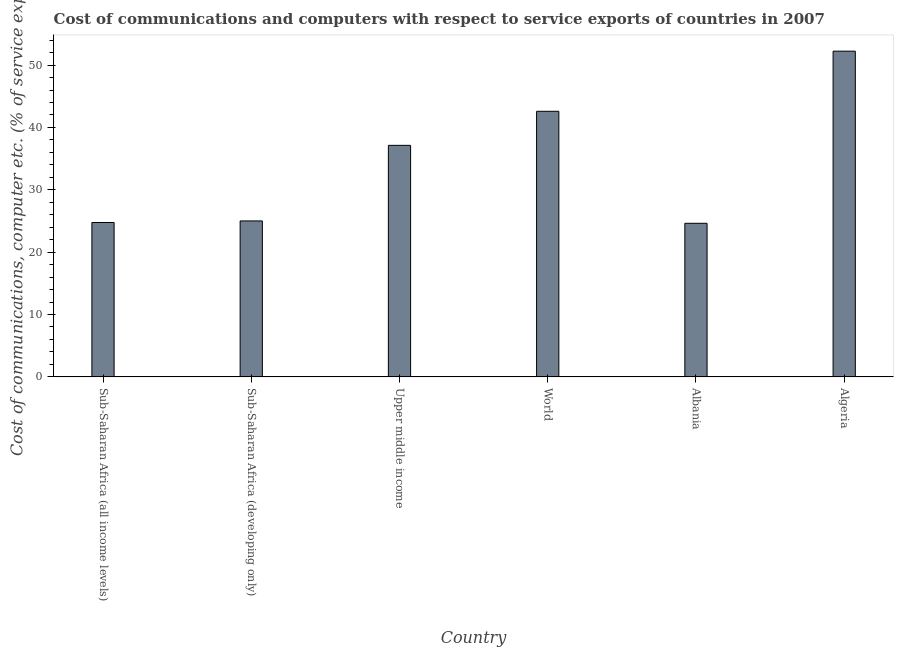Does the graph contain grids?
Your answer should be compact. No. What is the title of the graph?
Your answer should be compact. Cost of communications and computers with respect to service exports of countries in 2007. What is the label or title of the X-axis?
Give a very brief answer. Country. What is the label or title of the Y-axis?
Keep it short and to the point. Cost of communications, computer etc. (% of service exports). What is the cost of communications and computer in Sub-Saharan Africa (all income levels)?
Ensure brevity in your answer.  24.75. Across all countries, what is the maximum cost of communications and computer?
Offer a very short reply. 52.24. Across all countries, what is the minimum cost of communications and computer?
Offer a very short reply. 24.63. In which country was the cost of communications and computer maximum?
Offer a very short reply. Algeria. In which country was the cost of communications and computer minimum?
Make the answer very short. Albania. What is the sum of the cost of communications and computer?
Your answer should be very brief. 206.35. What is the difference between the cost of communications and computer in Sub-Saharan Africa (developing only) and Upper middle income?
Keep it short and to the point. -12.12. What is the average cost of communications and computer per country?
Offer a terse response. 34.39. What is the median cost of communications and computer?
Ensure brevity in your answer.  31.07. In how many countries, is the cost of communications and computer greater than 18 %?
Give a very brief answer. 6. What is the ratio of the cost of communications and computer in Algeria to that in Upper middle income?
Your response must be concise. 1.41. What is the difference between the highest and the second highest cost of communications and computer?
Provide a short and direct response. 9.64. Is the sum of the cost of communications and computer in Algeria and Upper middle income greater than the maximum cost of communications and computer across all countries?
Provide a short and direct response. Yes. What is the difference between the highest and the lowest cost of communications and computer?
Offer a terse response. 27.6. In how many countries, is the cost of communications and computer greater than the average cost of communications and computer taken over all countries?
Offer a terse response. 3. How many bars are there?
Offer a very short reply. 6. Are all the bars in the graph horizontal?
Give a very brief answer. No. How many countries are there in the graph?
Offer a terse response. 6. What is the difference between two consecutive major ticks on the Y-axis?
Give a very brief answer. 10. What is the Cost of communications, computer etc. (% of service exports) in Sub-Saharan Africa (all income levels)?
Offer a very short reply. 24.75. What is the Cost of communications, computer etc. (% of service exports) in Sub-Saharan Africa (developing only)?
Provide a succinct answer. 25.01. What is the Cost of communications, computer etc. (% of service exports) in Upper middle income?
Give a very brief answer. 37.13. What is the Cost of communications, computer etc. (% of service exports) of World?
Your answer should be compact. 42.59. What is the Cost of communications, computer etc. (% of service exports) in Albania?
Provide a short and direct response. 24.63. What is the Cost of communications, computer etc. (% of service exports) in Algeria?
Your response must be concise. 52.24. What is the difference between the Cost of communications, computer etc. (% of service exports) in Sub-Saharan Africa (all income levels) and Sub-Saharan Africa (developing only)?
Keep it short and to the point. -0.25. What is the difference between the Cost of communications, computer etc. (% of service exports) in Sub-Saharan Africa (all income levels) and Upper middle income?
Your answer should be compact. -12.38. What is the difference between the Cost of communications, computer etc. (% of service exports) in Sub-Saharan Africa (all income levels) and World?
Keep it short and to the point. -17.84. What is the difference between the Cost of communications, computer etc. (% of service exports) in Sub-Saharan Africa (all income levels) and Albania?
Provide a succinct answer. 0.12. What is the difference between the Cost of communications, computer etc. (% of service exports) in Sub-Saharan Africa (all income levels) and Algeria?
Give a very brief answer. -27.48. What is the difference between the Cost of communications, computer etc. (% of service exports) in Sub-Saharan Africa (developing only) and Upper middle income?
Ensure brevity in your answer.  -12.12. What is the difference between the Cost of communications, computer etc. (% of service exports) in Sub-Saharan Africa (developing only) and World?
Provide a short and direct response. -17.58. What is the difference between the Cost of communications, computer etc. (% of service exports) in Sub-Saharan Africa (developing only) and Albania?
Make the answer very short. 0.38. What is the difference between the Cost of communications, computer etc. (% of service exports) in Sub-Saharan Africa (developing only) and Algeria?
Ensure brevity in your answer.  -27.23. What is the difference between the Cost of communications, computer etc. (% of service exports) in Upper middle income and World?
Provide a short and direct response. -5.46. What is the difference between the Cost of communications, computer etc. (% of service exports) in Upper middle income and Albania?
Your response must be concise. 12.5. What is the difference between the Cost of communications, computer etc. (% of service exports) in Upper middle income and Algeria?
Your answer should be very brief. -15.11. What is the difference between the Cost of communications, computer etc. (% of service exports) in World and Albania?
Offer a very short reply. 17.96. What is the difference between the Cost of communications, computer etc. (% of service exports) in World and Algeria?
Make the answer very short. -9.64. What is the difference between the Cost of communications, computer etc. (% of service exports) in Albania and Algeria?
Give a very brief answer. -27.6. What is the ratio of the Cost of communications, computer etc. (% of service exports) in Sub-Saharan Africa (all income levels) to that in Sub-Saharan Africa (developing only)?
Provide a short and direct response. 0.99. What is the ratio of the Cost of communications, computer etc. (% of service exports) in Sub-Saharan Africa (all income levels) to that in Upper middle income?
Offer a very short reply. 0.67. What is the ratio of the Cost of communications, computer etc. (% of service exports) in Sub-Saharan Africa (all income levels) to that in World?
Your answer should be compact. 0.58. What is the ratio of the Cost of communications, computer etc. (% of service exports) in Sub-Saharan Africa (all income levels) to that in Albania?
Your response must be concise. 1. What is the ratio of the Cost of communications, computer etc. (% of service exports) in Sub-Saharan Africa (all income levels) to that in Algeria?
Offer a very short reply. 0.47. What is the ratio of the Cost of communications, computer etc. (% of service exports) in Sub-Saharan Africa (developing only) to that in Upper middle income?
Give a very brief answer. 0.67. What is the ratio of the Cost of communications, computer etc. (% of service exports) in Sub-Saharan Africa (developing only) to that in World?
Ensure brevity in your answer.  0.59. What is the ratio of the Cost of communications, computer etc. (% of service exports) in Sub-Saharan Africa (developing only) to that in Algeria?
Your answer should be very brief. 0.48. What is the ratio of the Cost of communications, computer etc. (% of service exports) in Upper middle income to that in World?
Provide a short and direct response. 0.87. What is the ratio of the Cost of communications, computer etc. (% of service exports) in Upper middle income to that in Albania?
Your answer should be compact. 1.51. What is the ratio of the Cost of communications, computer etc. (% of service exports) in Upper middle income to that in Algeria?
Make the answer very short. 0.71. What is the ratio of the Cost of communications, computer etc. (% of service exports) in World to that in Albania?
Provide a short and direct response. 1.73. What is the ratio of the Cost of communications, computer etc. (% of service exports) in World to that in Algeria?
Provide a short and direct response. 0.81. What is the ratio of the Cost of communications, computer etc. (% of service exports) in Albania to that in Algeria?
Provide a short and direct response. 0.47. 